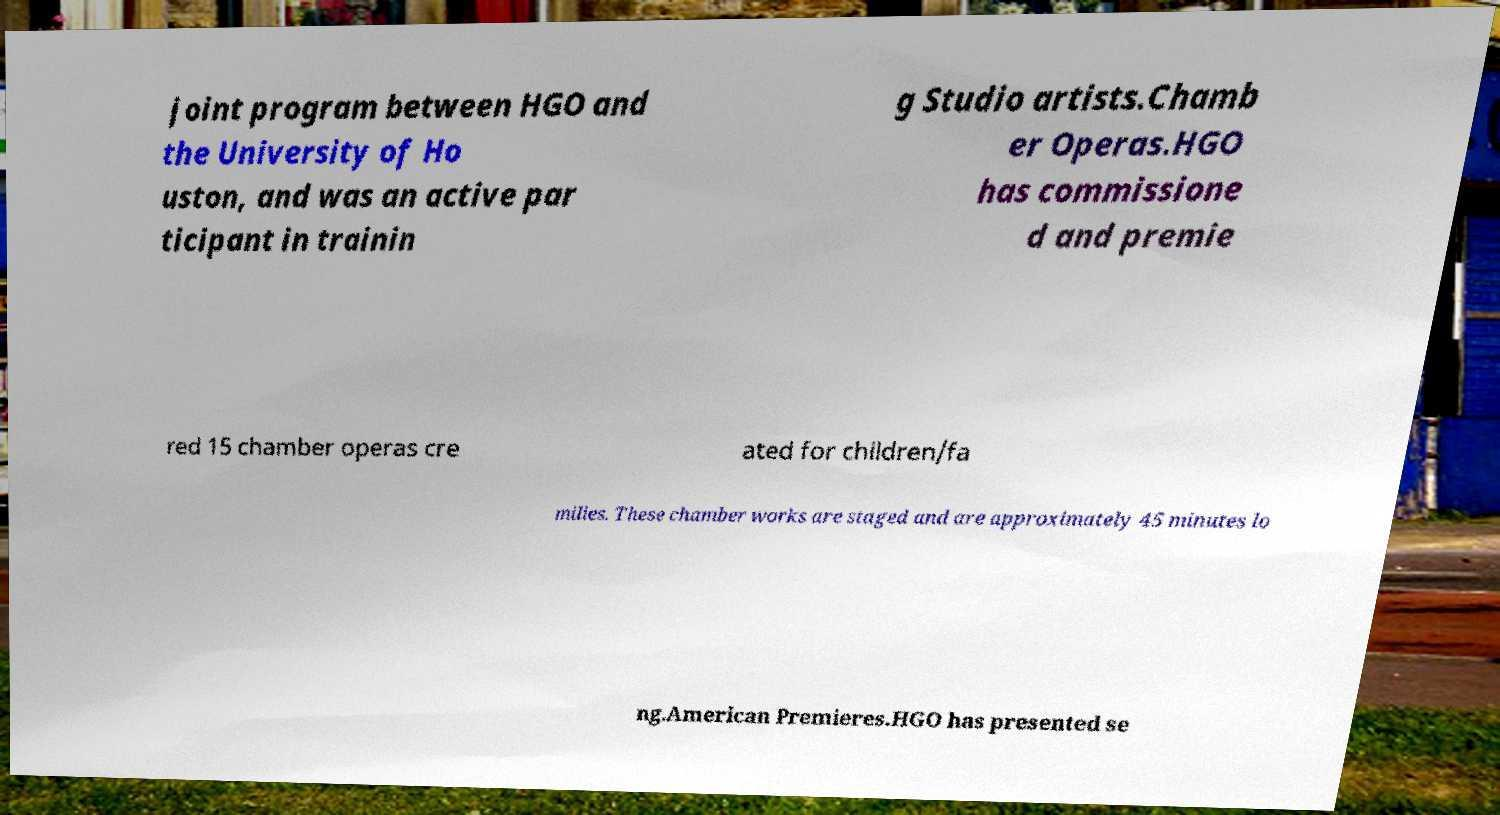There's text embedded in this image that I need extracted. Can you transcribe it verbatim? joint program between HGO and the University of Ho uston, and was an active par ticipant in trainin g Studio artists.Chamb er Operas.HGO has commissione d and premie red 15 chamber operas cre ated for children/fa milies. These chamber works are staged and are approximately 45 minutes lo ng.American Premieres.HGO has presented se 